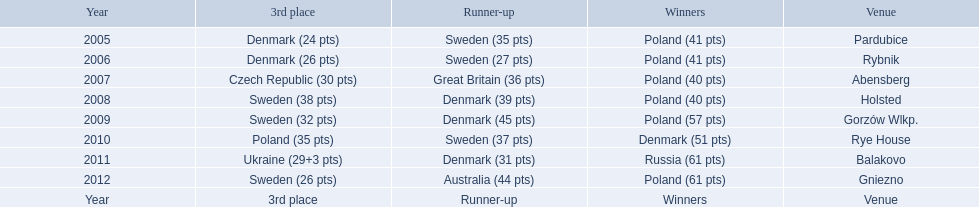Did holland win the 2010 championship? if not who did? Rye House. What did position did holland they rank? 3rd place. 